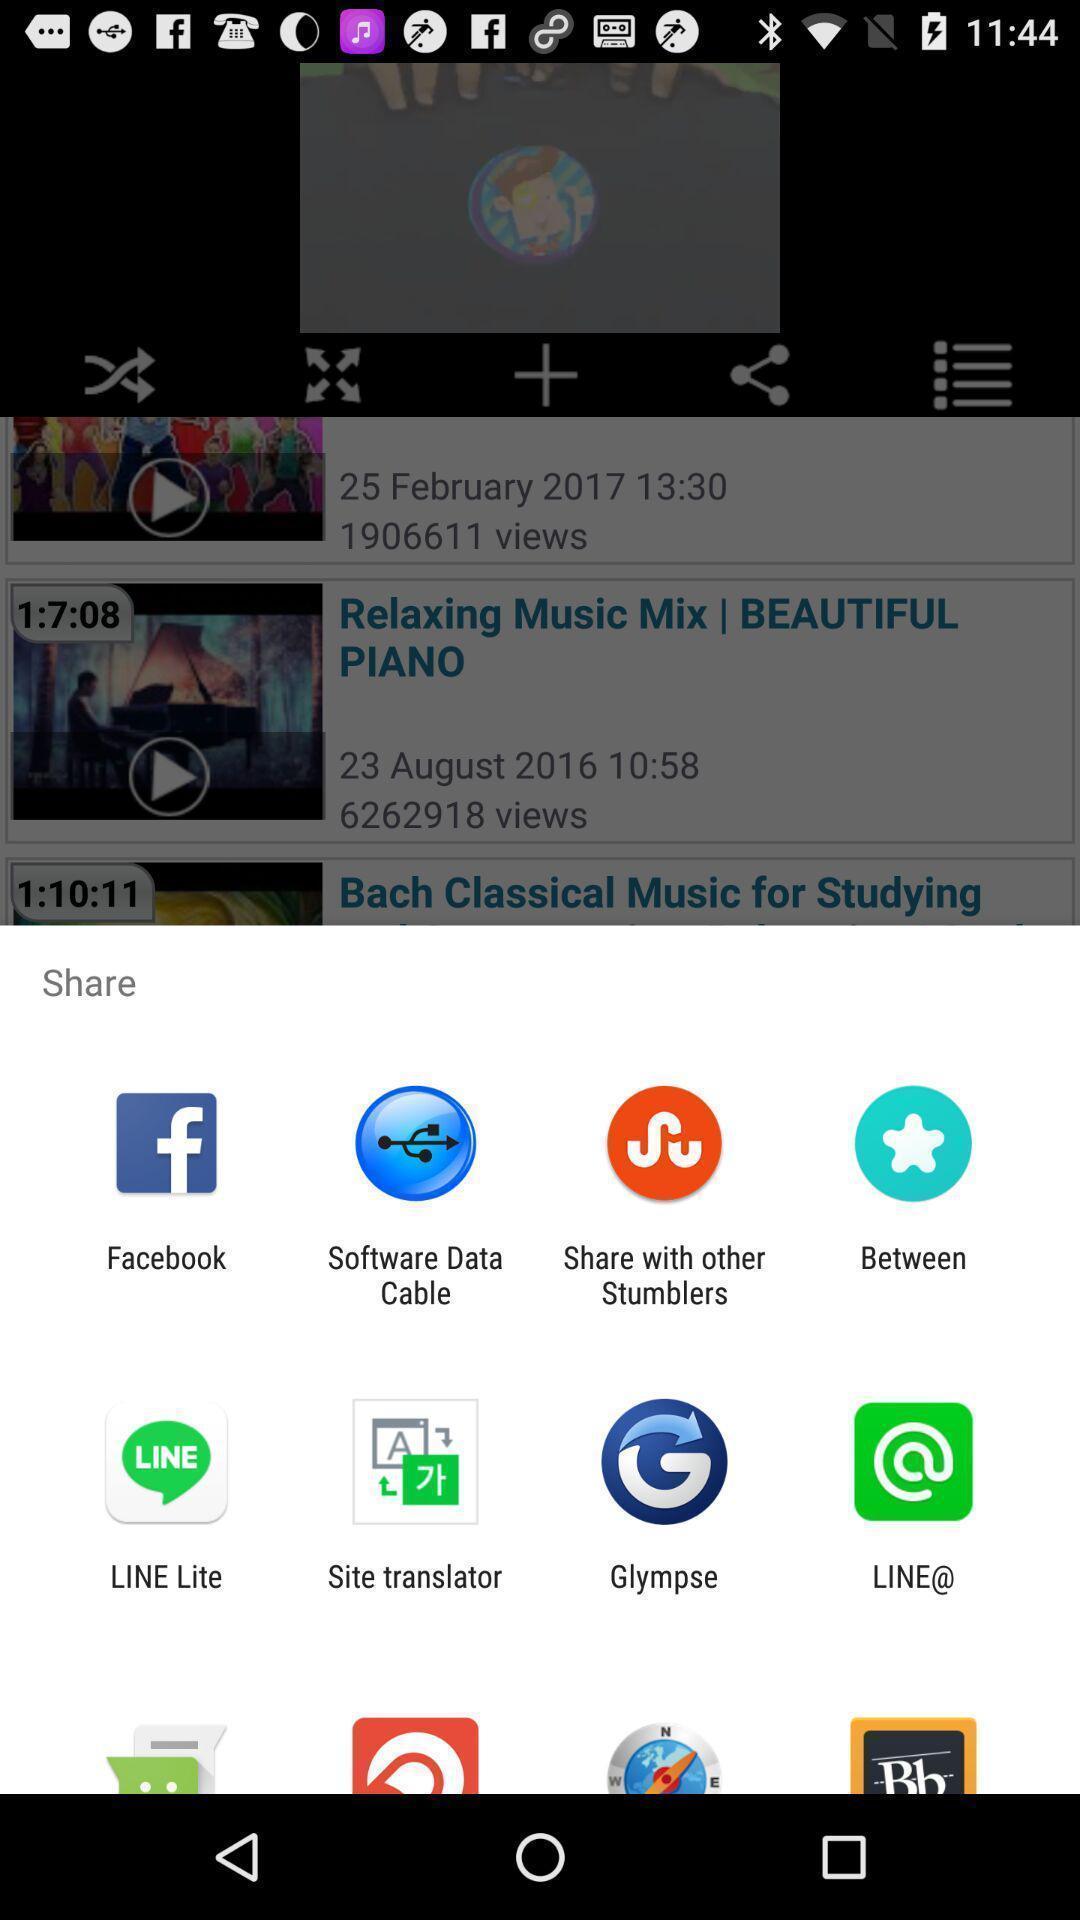Explain the elements present in this screenshot. Push up message for sharing data via social network. 